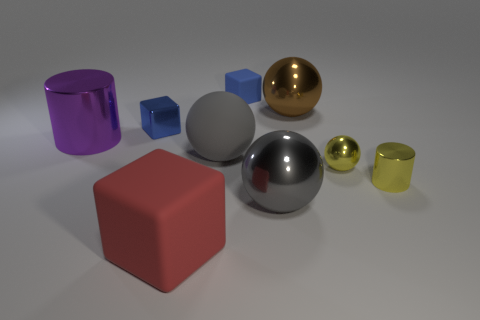Subtract all yellow cubes. Subtract all purple cylinders. How many cubes are left? 3 Add 1 big cylinders. How many objects exist? 10 Subtract all cylinders. How many objects are left? 7 Add 6 big gray metallic objects. How many big gray metallic objects exist? 7 Subtract 1 brown spheres. How many objects are left? 8 Subtract all blocks. Subtract all large matte objects. How many objects are left? 4 Add 7 large shiny cylinders. How many large shiny cylinders are left? 8 